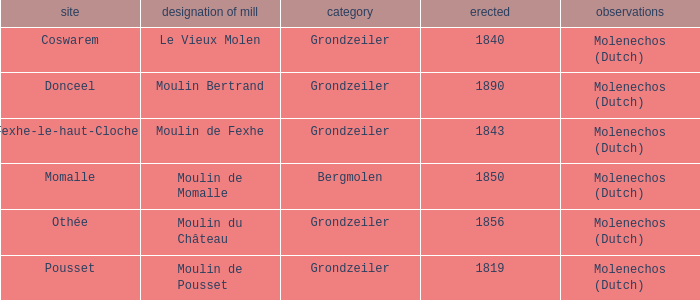What is year Built of the Moulin de Momalle Mill? 1850.0. 